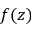Convert formula to latex. <formula><loc_0><loc_0><loc_500><loc_500>f ( z )</formula> 